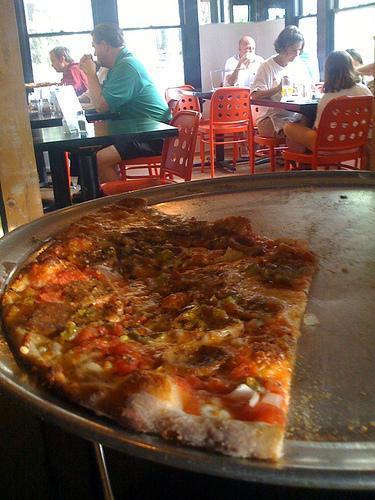How many pizzas are there?
Give a very brief answer. 1. How many holes are in the back of one chair?
Give a very brief answer. 12. How many chairs are in the photo?
Give a very brief answer. 3. How many people can you see?
Give a very brief answer. 3. How many cars are to the left of the carriage?
Give a very brief answer. 0. 